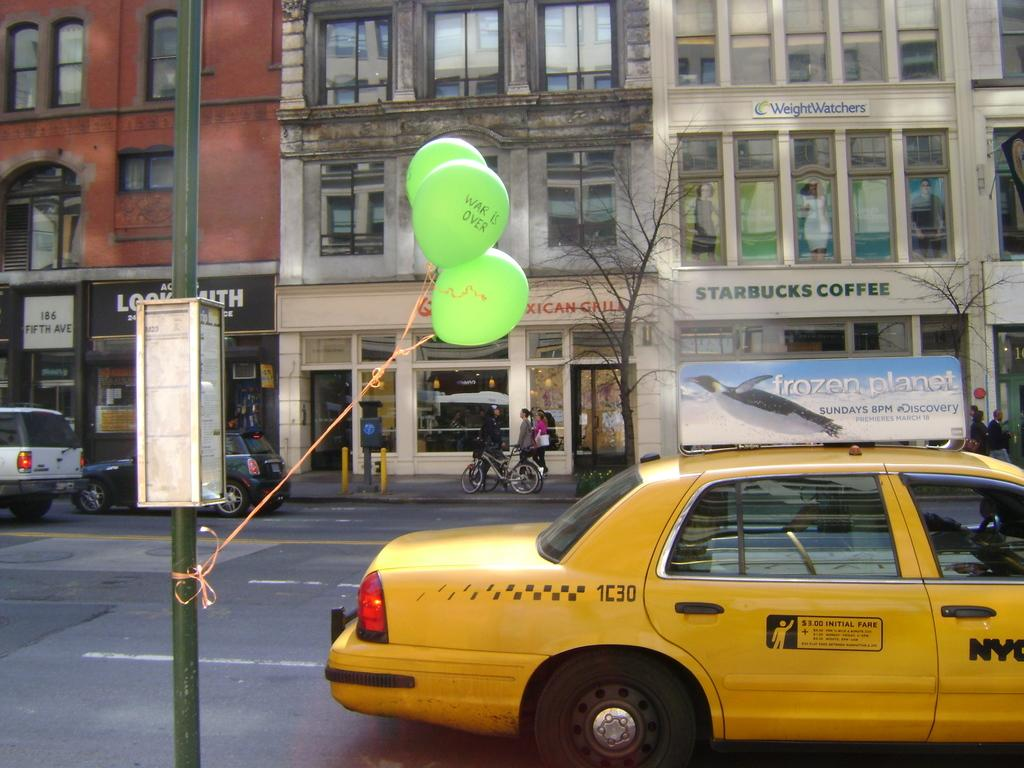Provide a one-sentence caption for the provided image. A city scene with a taxi in front with a topper advertising a show called Frozen Planet. 